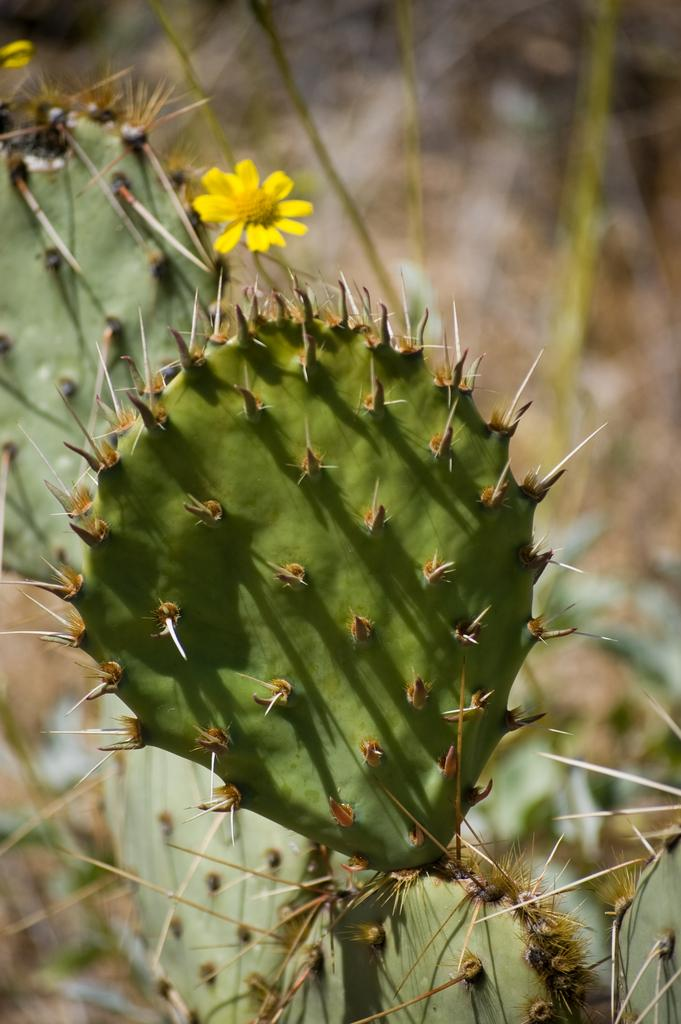What type of plant is in the image? There is a cactus in the image. What other object can be seen in the image? There is a yellow flower in the image. Can you describe the background of the image? The background of the image is blurry. What type of flag is visible in the image? There is no flag present in the image. What advice can be given to the jelly in the image? There is no jelly present in the image, so no advice can be given. 